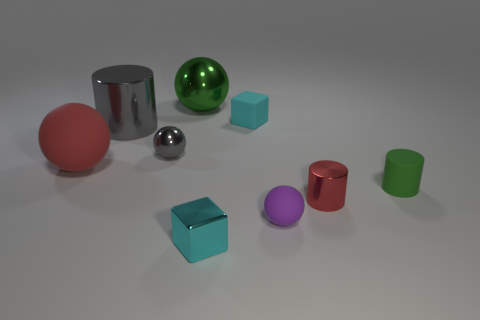What number of shiny spheres are the same size as the gray shiny cylinder?
Offer a very short reply. 1. Do the object that is right of the small red cylinder and the metal block to the left of the cyan matte cube have the same size?
Your response must be concise. Yes. What size is the rubber ball that is left of the large metallic ball?
Keep it short and to the point. Large. How big is the cyan thing in front of the cyan rubber cube to the right of the green metal thing?
Provide a succinct answer. Small. There is a gray object that is the same size as the purple matte object; what material is it?
Provide a succinct answer. Metal. Are there any large things in front of the cyan matte object?
Your answer should be compact. Yes. Are there the same number of tiny rubber objects left of the small matte cylinder and small balls?
Offer a terse response. Yes. There is a gray object that is the same size as the rubber block; what shape is it?
Provide a succinct answer. Sphere. What material is the tiny red object?
Make the answer very short. Metal. What color is the ball that is both in front of the big green thing and behind the large red matte thing?
Offer a terse response. Gray. 